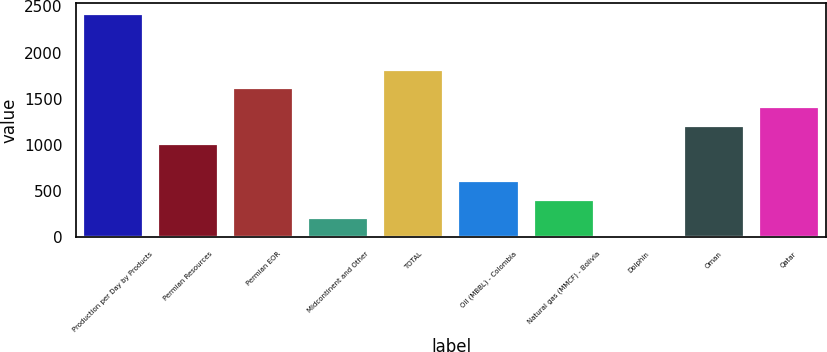Convert chart to OTSL. <chart><loc_0><loc_0><loc_500><loc_500><bar_chart><fcel>Production per Day by Products<fcel>Permian Resources<fcel>Permian EOR<fcel>Midcontinent and Other<fcel>TOTAL<fcel>Oil (MBBL) - Colombia<fcel>Natural gas (MMCF) - Bolivia<fcel>Dolphin<fcel>Oman<fcel>Qatar<nl><fcel>2415.4<fcel>1010.5<fcel>1612.6<fcel>207.7<fcel>1813.3<fcel>609.1<fcel>408.4<fcel>7<fcel>1211.2<fcel>1411.9<nl></chart> 